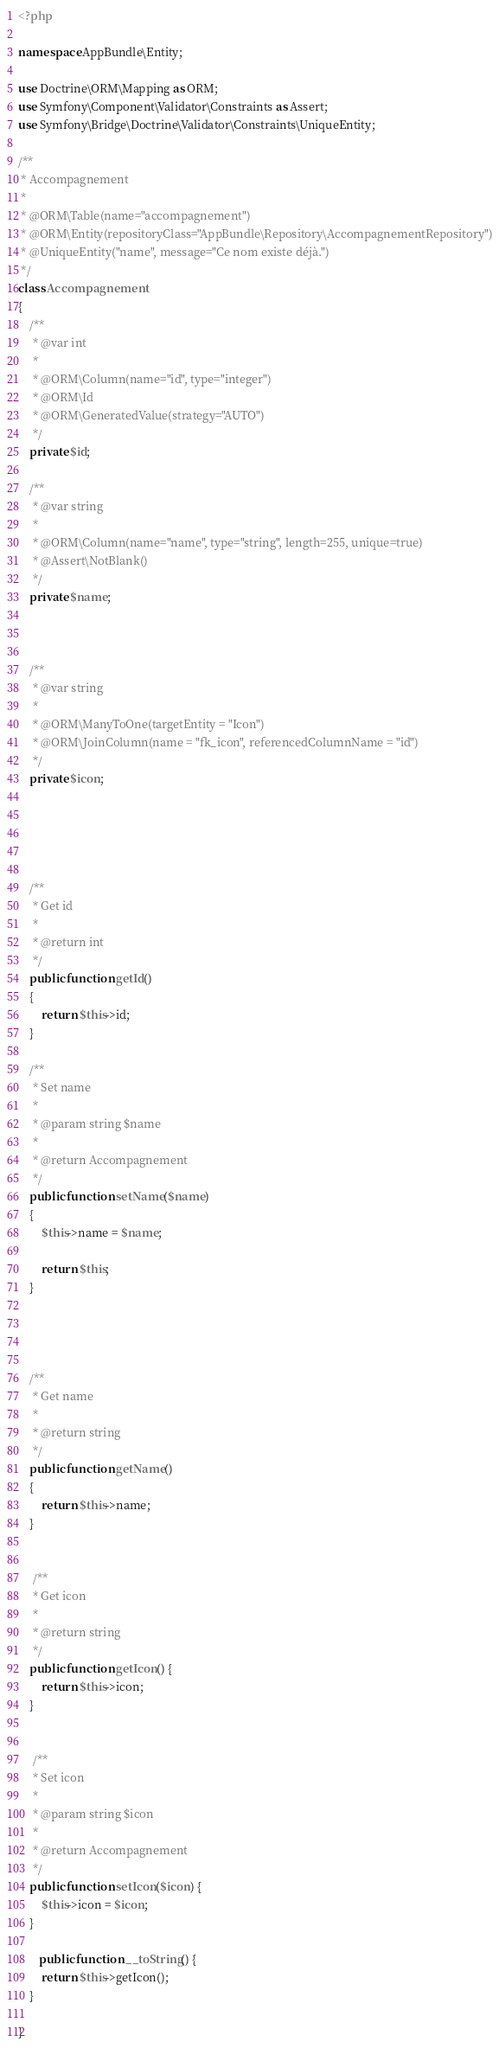Convert code to text. <code><loc_0><loc_0><loc_500><loc_500><_PHP_><?php

namespace AppBundle\Entity;

use Doctrine\ORM\Mapping as ORM;
use Symfony\Component\Validator\Constraints as Assert;
use Symfony\Bridge\Doctrine\Validator\Constraints\UniqueEntity;

/**
 * Accompagnement
 *
 * @ORM\Table(name="accompagnement")
 * @ORM\Entity(repositoryClass="AppBundle\Repository\AccompagnementRepository")
 * @UniqueEntity("name", message="Ce nom existe déjà.")
 */
class Accompagnement
{
    /**
     * @var int
     *
     * @ORM\Column(name="id", type="integer")
     * @ORM\Id
     * @ORM\GeneratedValue(strategy="AUTO")
     */
    private $id;

    /**
     * @var string
     *
     * @ORM\Column(name="name", type="string", length=255, unique=true)
     * @Assert\NotBlank()
     */
    private $name;
    
    
    
    /**
     * @var string
     *
     * @ORM\ManyToOne(targetEntity = "Icon")
     * @ORM\JoinColumn(name = "fk_icon", referencedColumnName = "id")
     */
    private $icon;

   
    
    

    /**
     * Get id
     *
     * @return int
     */
    public function getId()
    {
        return $this->id;
    }

    /**
     * Set name
     *
     * @param string $name
     *
     * @return Accompagnement
     */
    public function setName($name)
    {
        $this->name = $name;

        return $this;
    }
    
    
   
    
    /**
     * Get name
     *
     * @return string
     */
    public function getName()
    {
        return $this->name;
    }
    
    
     /**
     * Get icon
     *
     * @return string
     */
    public function getIcon() {
        return $this->icon;
    }
    
    
     /**
     * Set icon
     *
     * @param string $icon
     *
     * @return Accompagnement
     */
    public function setIcon($icon) {
        $this->icon = $icon;
    }

       public function __toString() {
        return $this->getIcon();
    }
    
}

</code> 